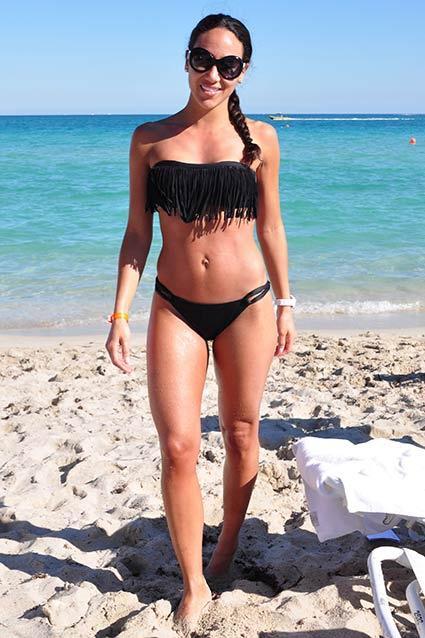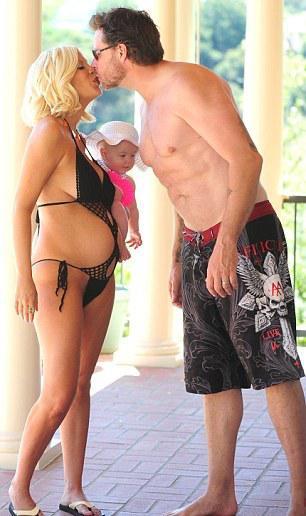The first image is the image on the left, the second image is the image on the right. Assess this claim about the two images: "There is at least one pregnant woman.". Correct or not? Answer yes or no. Yes. The first image is the image on the left, the second image is the image on the right. Considering the images on both sides, is "Right image shows three bikini-wearing women standing close together." valid? Answer yes or no. No. 